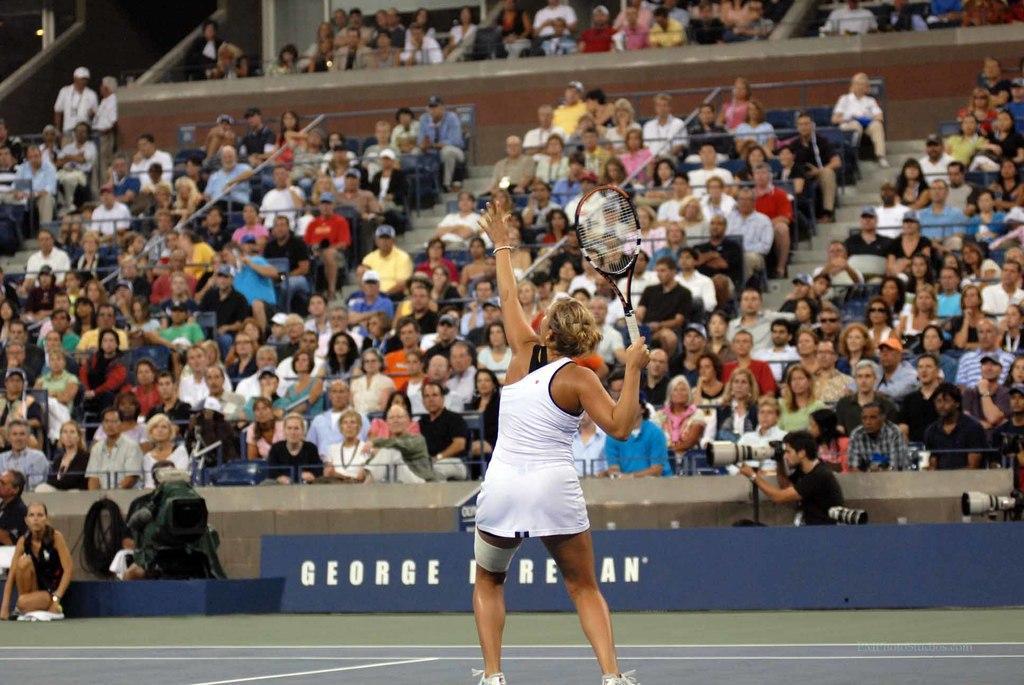Describe this image in one or two sentences. In this image there is a woman standing and playing a tennis and in back ground there are camera, hoarding, group of people sitting in a stadium. 